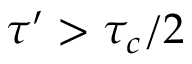<formula> <loc_0><loc_0><loc_500><loc_500>\tau ^ { \prime } > \tau _ { c } / 2</formula> 